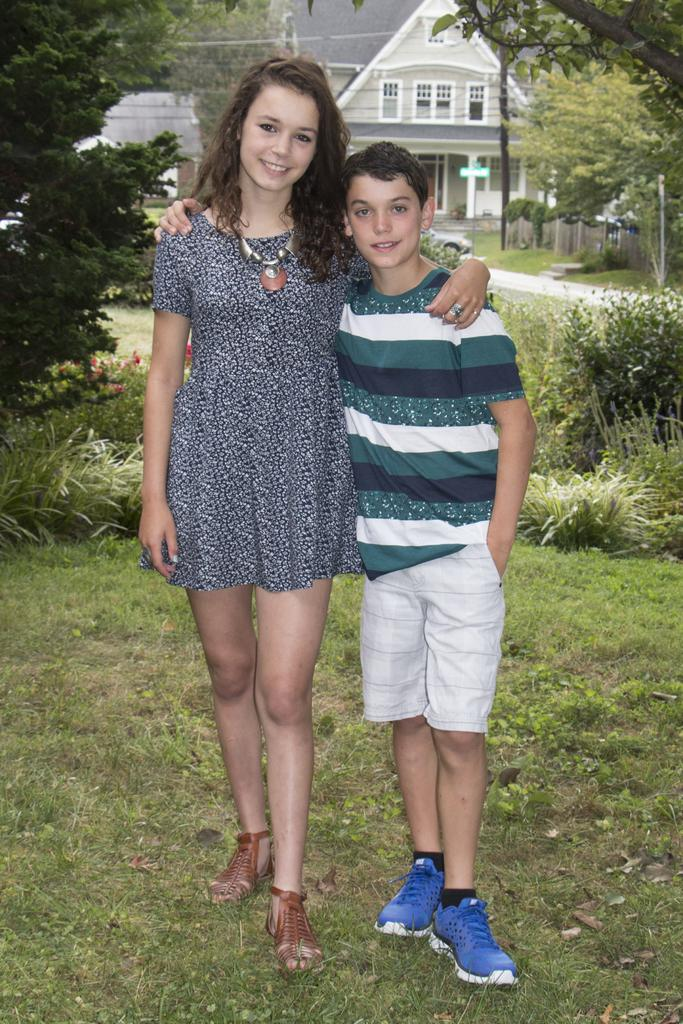How many people are in the image? There is a girl and a boy in the image. What type of terrain is visible in the image? There is grass visible in the image. What can be seen in the background of the image? There is a house, trees, and plants in the background of the image. What features does the house have? The house has windows and a door. What flavor of mint can be seen growing in the image? There is no mint visible in the image. What season is depicted in the image? The provided facts do not mention the season or weather conditions, so it cannot be determined from the image. 